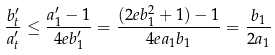<formula> <loc_0><loc_0><loc_500><loc_500>\frac { b ^ { \prime } _ { t } } { a ^ { \prime } _ { t } } \leq \frac { a ^ { \prime } _ { 1 } - 1 } { 4 e b ^ { \prime } _ { 1 } } = \frac { ( 2 e b _ { 1 } ^ { 2 } + 1 ) - 1 } { 4 e a _ { 1 } b _ { 1 } } = \frac { b _ { 1 } } { 2 a _ { 1 } }</formula> 